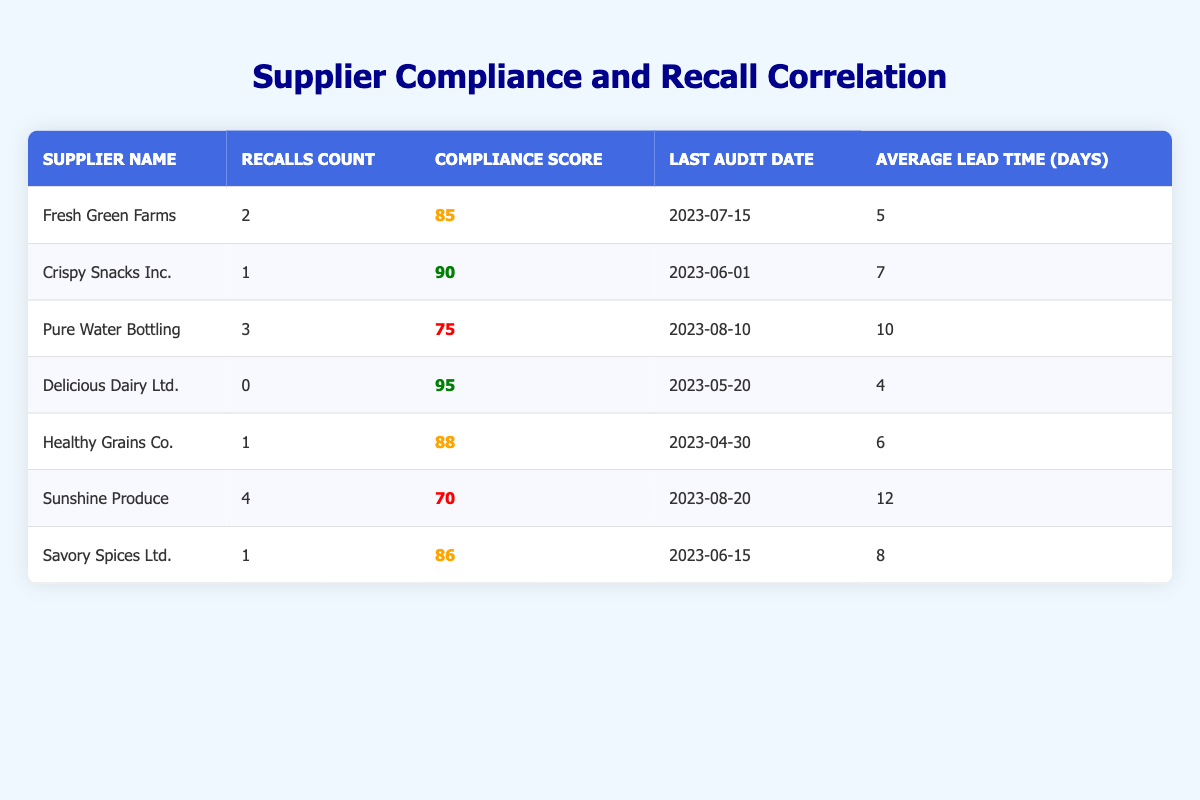What is the compliance score of Fresh Green Farms? The table shows the compliance score for each supplier. For Fresh Green Farms, it is listed directly next to its name in the compliance score column, which is 85.
Answer: 85 How many recalls did Sunshine Produce have? To find the number of recalls for Sunshine Produce, I look for its name in the table and check the recalls count column associated with it. Sunshine Produce has a recalls count of 4.
Answer: 4 Which supplier has the highest compliance score? I can compare the compliance scores of all suppliers listed in the table. Delicious Dairy Ltd. has the highest compliance score at 95.
Answer: Delicious Dairy Ltd Is there a supplier with zero recalls? I check the recalls count for each supplier, and I find that Delicious Dairy Ltd. has a recalls count of 0.
Answer: Yes What is the average compliance score of all suppliers? To find the average compliance score, I first sum the compliance scores: (85 + 90 + 75 + 95 + 88 + 70 + 86) = 619. Then, I divide by the total number of suppliers, which is 7. The average is 619 / 7 = 88.43.
Answer: 88.43 Which supplier had the last audit date in August 2023? I look at the last audit date for each supplier listed in the table. Sunshine Produce has the last audit date of August 20, 2023.
Answer: Sunshine Produce How many suppliers have a compliance score below 80? I scan through the compliance scores of each supplier and find that only Sunshine Produce has a score below 80, which is 70. Therefore, there is only 1 supplier in this category.
Answer: 1 What is the difference in recalls count between Pure Water Bottling and Crispy Snacks Inc.? I find the recalls count for both suppliers: Pure Water Bottling has 3 recalls, and Crispy Snacks Inc. has 1 recall. The difference is 3 - 1 = 2.
Answer: 2 What is the relationship observed between compliance scores and recalls count? By examining the table, I can see that, generally, higher compliance scores correlate with fewer recalls. For example, Delicious Dairy Ltd. has the highest compliance score (95) and zero recalls, while Sunshine Produce has the lowest compliance score (70) and the highest recalls (4).
Answer: Higher scores correlate with fewer recalls 